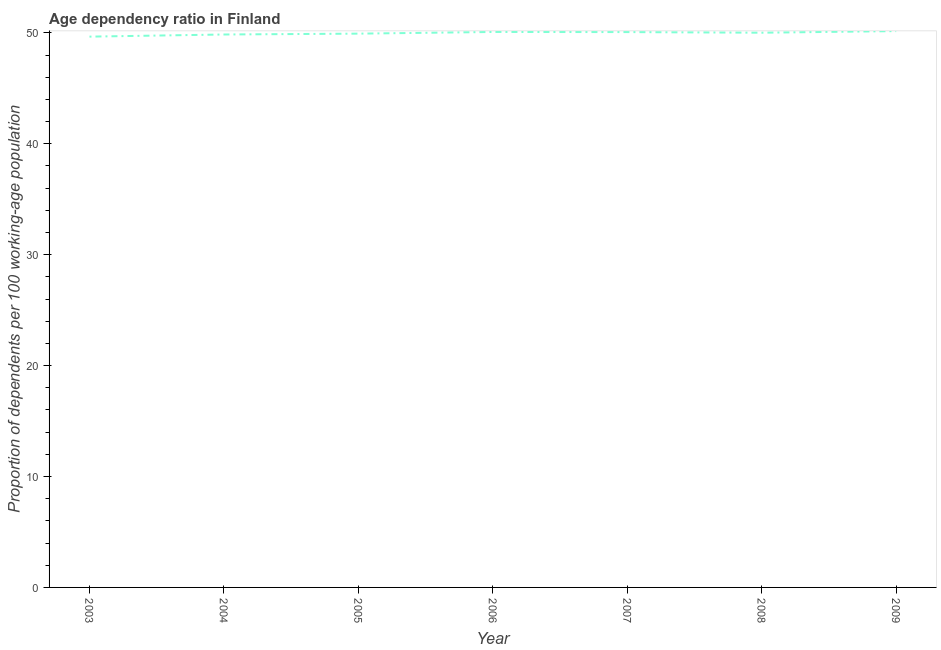What is the age dependency ratio in 2006?
Your response must be concise. 50.08. Across all years, what is the maximum age dependency ratio?
Your response must be concise. 50.16. Across all years, what is the minimum age dependency ratio?
Your answer should be very brief. 49.66. In which year was the age dependency ratio minimum?
Your response must be concise. 2003. What is the sum of the age dependency ratio?
Keep it short and to the point. 349.75. What is the difference between the age dependency ratio in 2005 and 2006?
Provide a short and direct response. -0.15. What is the average age dependency ratio per year?
Provide a short and direct response. 49.96. What is the median age dependency ratio?
Ensure brevity in your answer.  50.01. Do a majority of the years between 2004 and 2007 (inclusive) have age dependency ratio greater than 46 ?
Provide a succinct answer. Yes. What is the ratio of the age dependency ratio in 2005 to that in 2008?
Your answer should be compact. 1. Is the difference between the age dependency ratio in 2008 and 2009 greater than the difference between any two years?
Offer a terse response. No. What is the difference between the highest and the second highest age dependency ratio?
Your response must be concise. 0.08. What is the difference between the highest and the lowest age dependency ratio?
Your answer should be very brief. 0.5. In how many years, is the age dependency ratio greater than the average age dependency ratio taken over all years?
Provide a short and direct response. 4. Does the age dependency ratio monotonically increase over the years?
Ensure brevity in your answer.  No. How many years are there in the graph?
Offer a terse response. 7. What is the title of the graph?
Offer a very short reply. Age dependency ratio in Finland. What is the label or title of the Y-axis?
Ensure brevity in your answer.  Proportion of dependents per 100 working-age population. What is the Proportion of dependents per 100 working-age population of 2003?
Your answer should be very brief. 49.66. What is the Proportion of dependents per 100 working-age population in 2004?
Provide a succinct answer. 49.85. What is the Proportion of dependents per 100 working-age population of 2005?
Your answer should be very brief. 49.93. What is the Proportion of dependents per 100 working-age population of 2006?
Your answer should be very brief. 50.08. What is the Proportion of dependents per 100 working-age population of 2007?
Offer a very short reply. 50.07. What is the Proportion of dependents per 100 working-age population of 2008?
Offer a terse response. 50.01. What is the Proportion of dependents per 100 working-age population in 2009?
Your response must be concise. 50.16. What is the difference between the Proportion of dependents per 100 working-age population in 2003 and 2004?
Ensure brevity in your answer.  -0.19. What is the difference between the Proportion of dependents per 100 working-age population in 2003 and 2005?
Your answer should be very brief. -0.27. What is the difference between the Proportion of dependents per 100 working-age population in 2003 and 2006?
Your answer should be compact. -0.42. What is the difference between the Proportion of dependents per 100 working-age population in 2003 and 2007?
Keep it short and to the point. -0.41. What is the difference between the Proportion of dependents per 100 working-age population in 2003 and 2008?
Offer a very short reply. -0.35. What is the difference between the Proportion of dependents per 100 working-age population in 2003 and 2009?
Your answer should be very brief. -0.5. What is the difference between the Proportion of dependents per 100 working-age population in 2004 and 2005?
Give a very brief answer. -0.08. What is the difference between the Proportion of dependents per 100 working-age population in 2004 and 2006?
Make the answer very short. -0.23. What is the difference between the Proportion of dependents per 100 working-age population in 2004 and 2007?
Ensure brevity in your answer.  -0.22. What is the difference between the Proportion of dependents per 100 working-age population in 2004 and 2008?
Provide a short and direct response. -0.16. What is the difference between the Proportion of dependents per 100 working-age population in 2004 and 2009?
Make the answer very short. -0.31. What is the difference between the Proportion of dependents per 100 working-age population in 2005 and 2006?
Your answer should be very brief. -0.15. What is the difference between the Proportion of dependents per 100 working-age population in 2005 and 2007?
Ensure brevity in your answer.  -0.14. What is the difference between the Proportion of dependents per 100 working-age population in 2005 and 2008?
Your answer should be compact. -0.08. What is the difference between the Proportion of dependents per 100 working-age population in 2005 and 2009?
Your answer should be very brief. -0.23. What is the difference between the Proportion of dependents per 100 working-age population in 2006 and 2007?
Ensure brevity in your answer.  0.01. What is the difference between the Proportion of dependents per 100 working-age population in 2006 and 2008?
Ensure brevity in your answer.  0.07. What is the difference between the Proportion of dependents per 100 working-age population in 2006 and 2009?
Provide a short and direct response. -0.08. What is the difference between the Proportion of dependents per 100 working-age population in 2007 and 2008?
Ensure brevity in your answer.  0.06. What is the difference between the Proportion of dependents per 100 working-age population in 2007 and 2009?
Your answer should be very brief. -0.09. What is the difference between the Proportion of dependents per 100 working-age population in 2008 and 2009?
Your answer should be compact. -0.15. What is the ratio of the Proportion of dependents per 100 working-age population in 2003 to that in 2004?
Give a very brief answer. 1. What is the ratio of the Proportion of dependents per 100 working-age population in 2003 to that in 2005?
Keep it short and to the point. 0.99. What is the ratio of the Proportion of dependents per 100 working-age population in 2003 to that in 2008?
Give a very brief answer. 0.99. What is the ratio of the Proportion of dependents per 100 working-age population in 2003 to that in 2009?
Your answer should be very brief. 0.99. What is the ratio of the Proportion of dependents per 100 working-age population in 2004 to that in 2005?
Ensure brevity in your answer.  1. What is the ratio of the Proportion of dependents per 100 working-age population in 2004 to that in 2006?
Provide a succinct answer. 0.99. What is the ratio of the Proportion of dependents per 100 working-age population in 2004 to that in 2007?
Offer a terse response. 1. What is the ratio of the Proportion of dependents per 100 working-age population in 2005 to that in 2006?
Your response must be concise. 1. What is the ratio of the Proportion of dependents per 100 working-age population in 2006 to that in 2007?
Your answer should be compact. 1. What is the ratio of the Proportion of dependents per 100 working-age population in 2006 to that in 2008?
Make the answer very short. 1. What is the ratio of the Proportion of dependents per 100 working-age population in 2007 to that in 2008?
Provide a succinct answer. 1. 